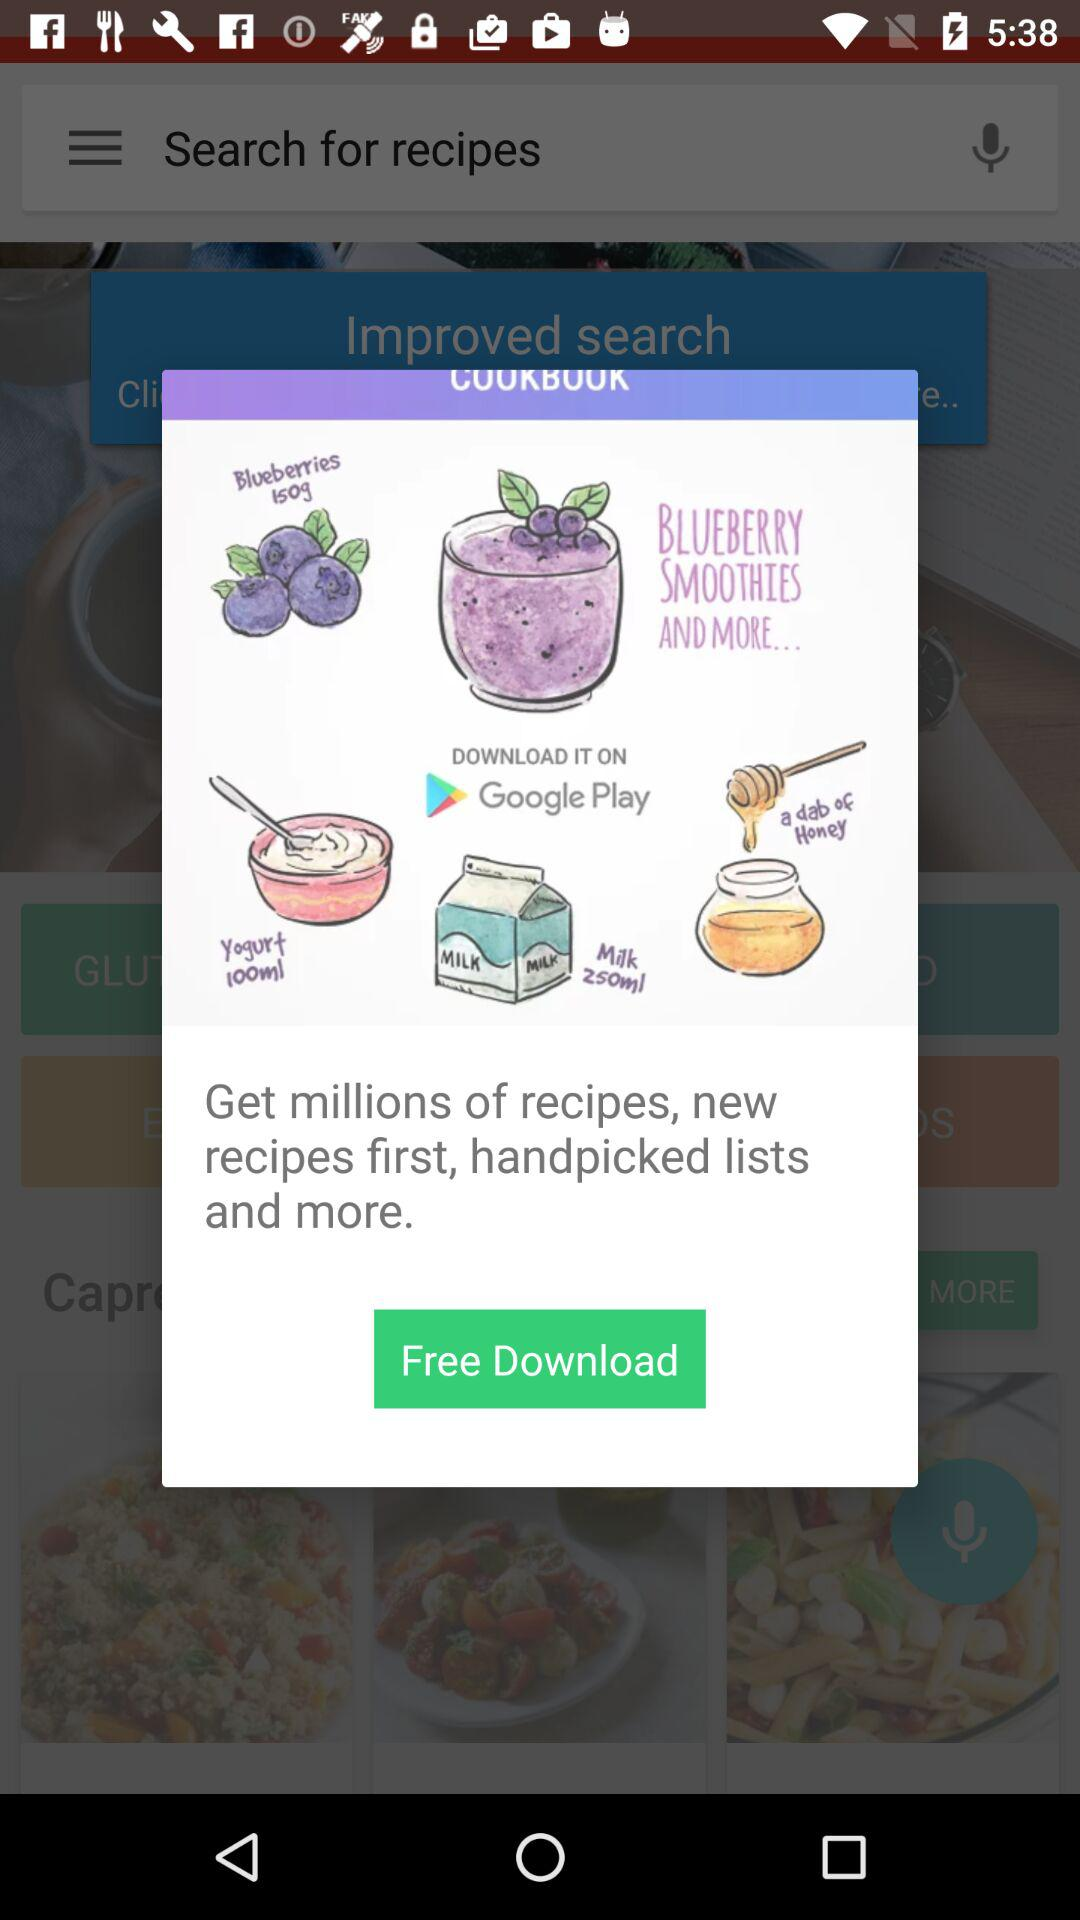How many recipes can we get? You can get millions of recipes. 